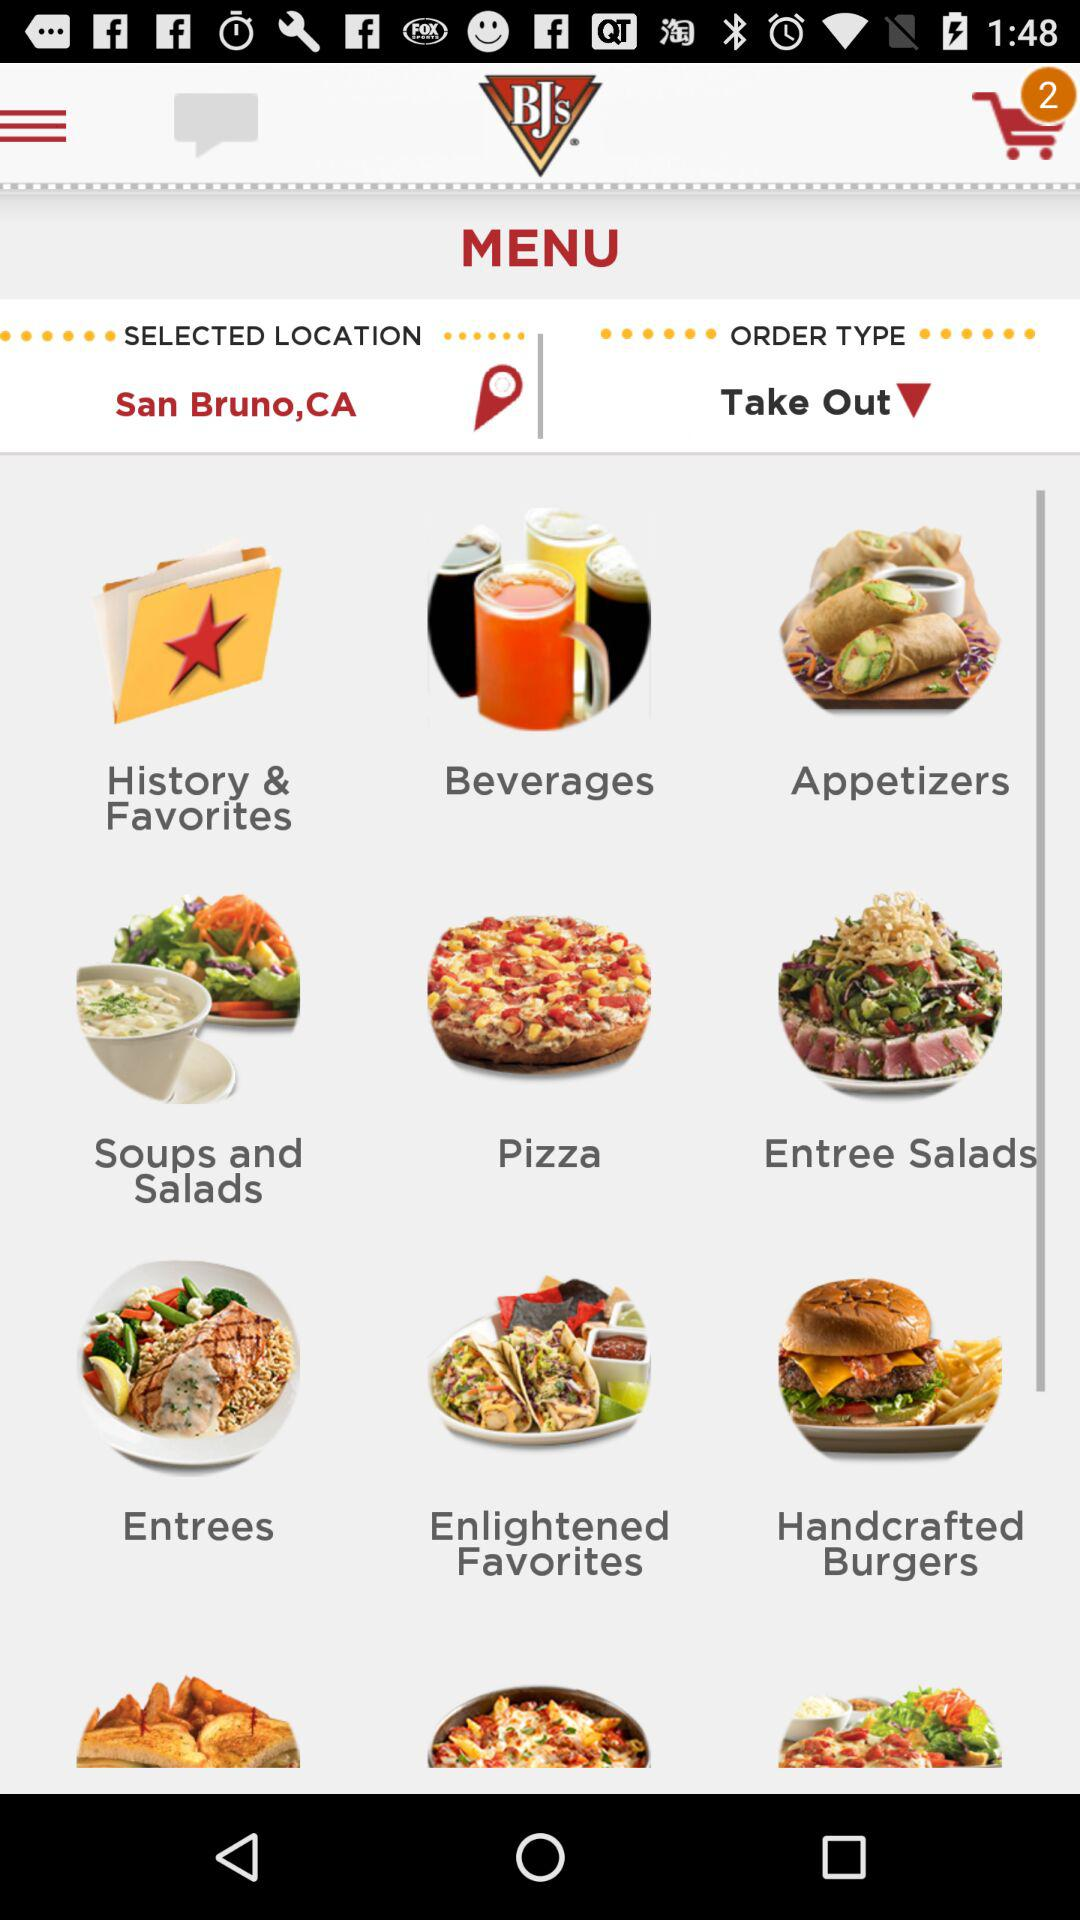What is the order type? The order type is "Take Out". 